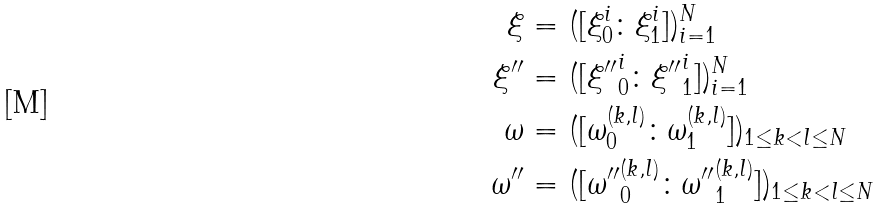Convert formula to latex. <formula><loc_0><loc_0><loc_500><loc_500>\xi & = ( [ \xi _ { 0 } ^ { i } \colon \xi _ { 1 } ^ { i } ] ) _ { i = 1 } ^ { N } \\ { \xi } ^ { \prime \prime } & = ( [ { \xi ^ { \prime \prime } } _ { 0 } ^ { i } \colon { \xi ^ { \prime \prime } } _ { 1 } ^ { i } ] ) _ { i = 1 } ^ { N } \\ \omega & = ( [ \omega _ { 0 } ^ { ( k , l ) } \colon \omega _ { 1 } ^ { ( k , l ) } ] ) _ { 1 \leq k < l \leq N } \\ { \omega } ^ { \prime \prime } & = ( [ { \omega ^ { \prime \prime } } _ { 0 } ^ { ( k , l ) } \colon { \omega ^ { \prime \prime } } _ { 1 } ^ { ( k , l ) } ] ) _ { 1 \leq k < l \leq N }</formula> 